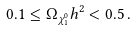<formula> <loc_0><loc_0><loc_500><loc_500>0 . 1 \leq \Omega _ { \chi _ { 1 } ^ { 0 } } h ^ { 2 } < 0 . 5 \, .</formula> 